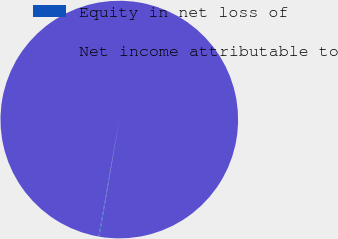Convert chart to OTSL. <chart><loc_0><loc_0><loc_500><loc_500><pie_chart><fcel>Equity in net loss of<fcel>Net income attributable to<nl><fcel>0.12%<fcel>99.88%<nl></chart> 